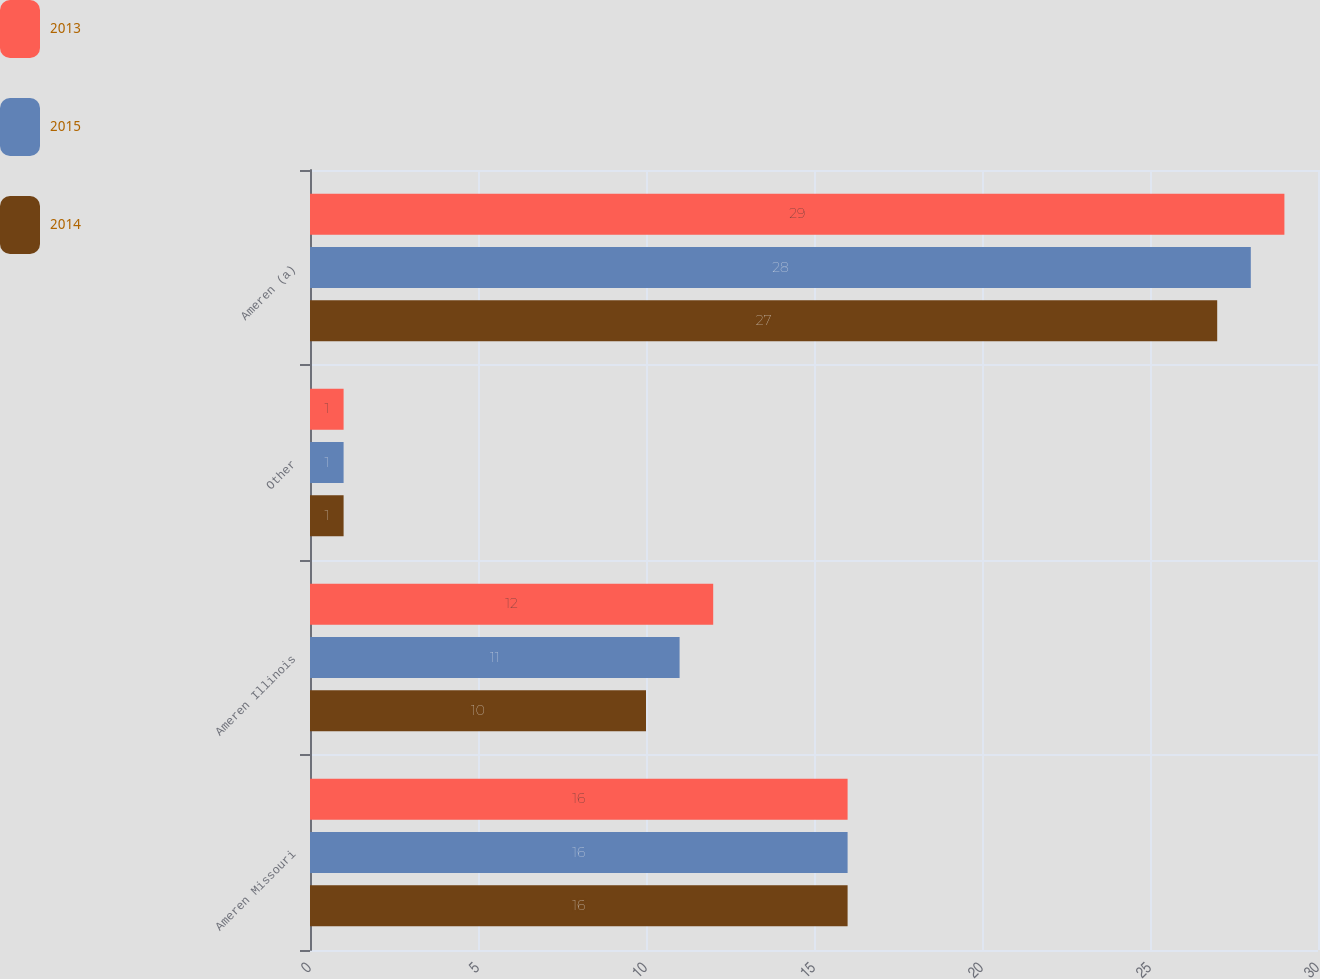Convert chart to OTSL. <chart><loc_0><loc_0><loc_500><loc_500><stacked_bar_chart><ecel><fcel>Ameren Missouri<fcel>Ameren Illinois<fcel>Other<fcel>Ameren (a)<nl><fcel>2013<fcel>16<fcel>12<fcel>1<fcel>29<nl><fcel>2015<fcel>16<fcel>11<fcel>1<fcel>28<nl><fcel>2014<fcel>16<fcel>10<fcel>1<fcel>27<nl></chart> 